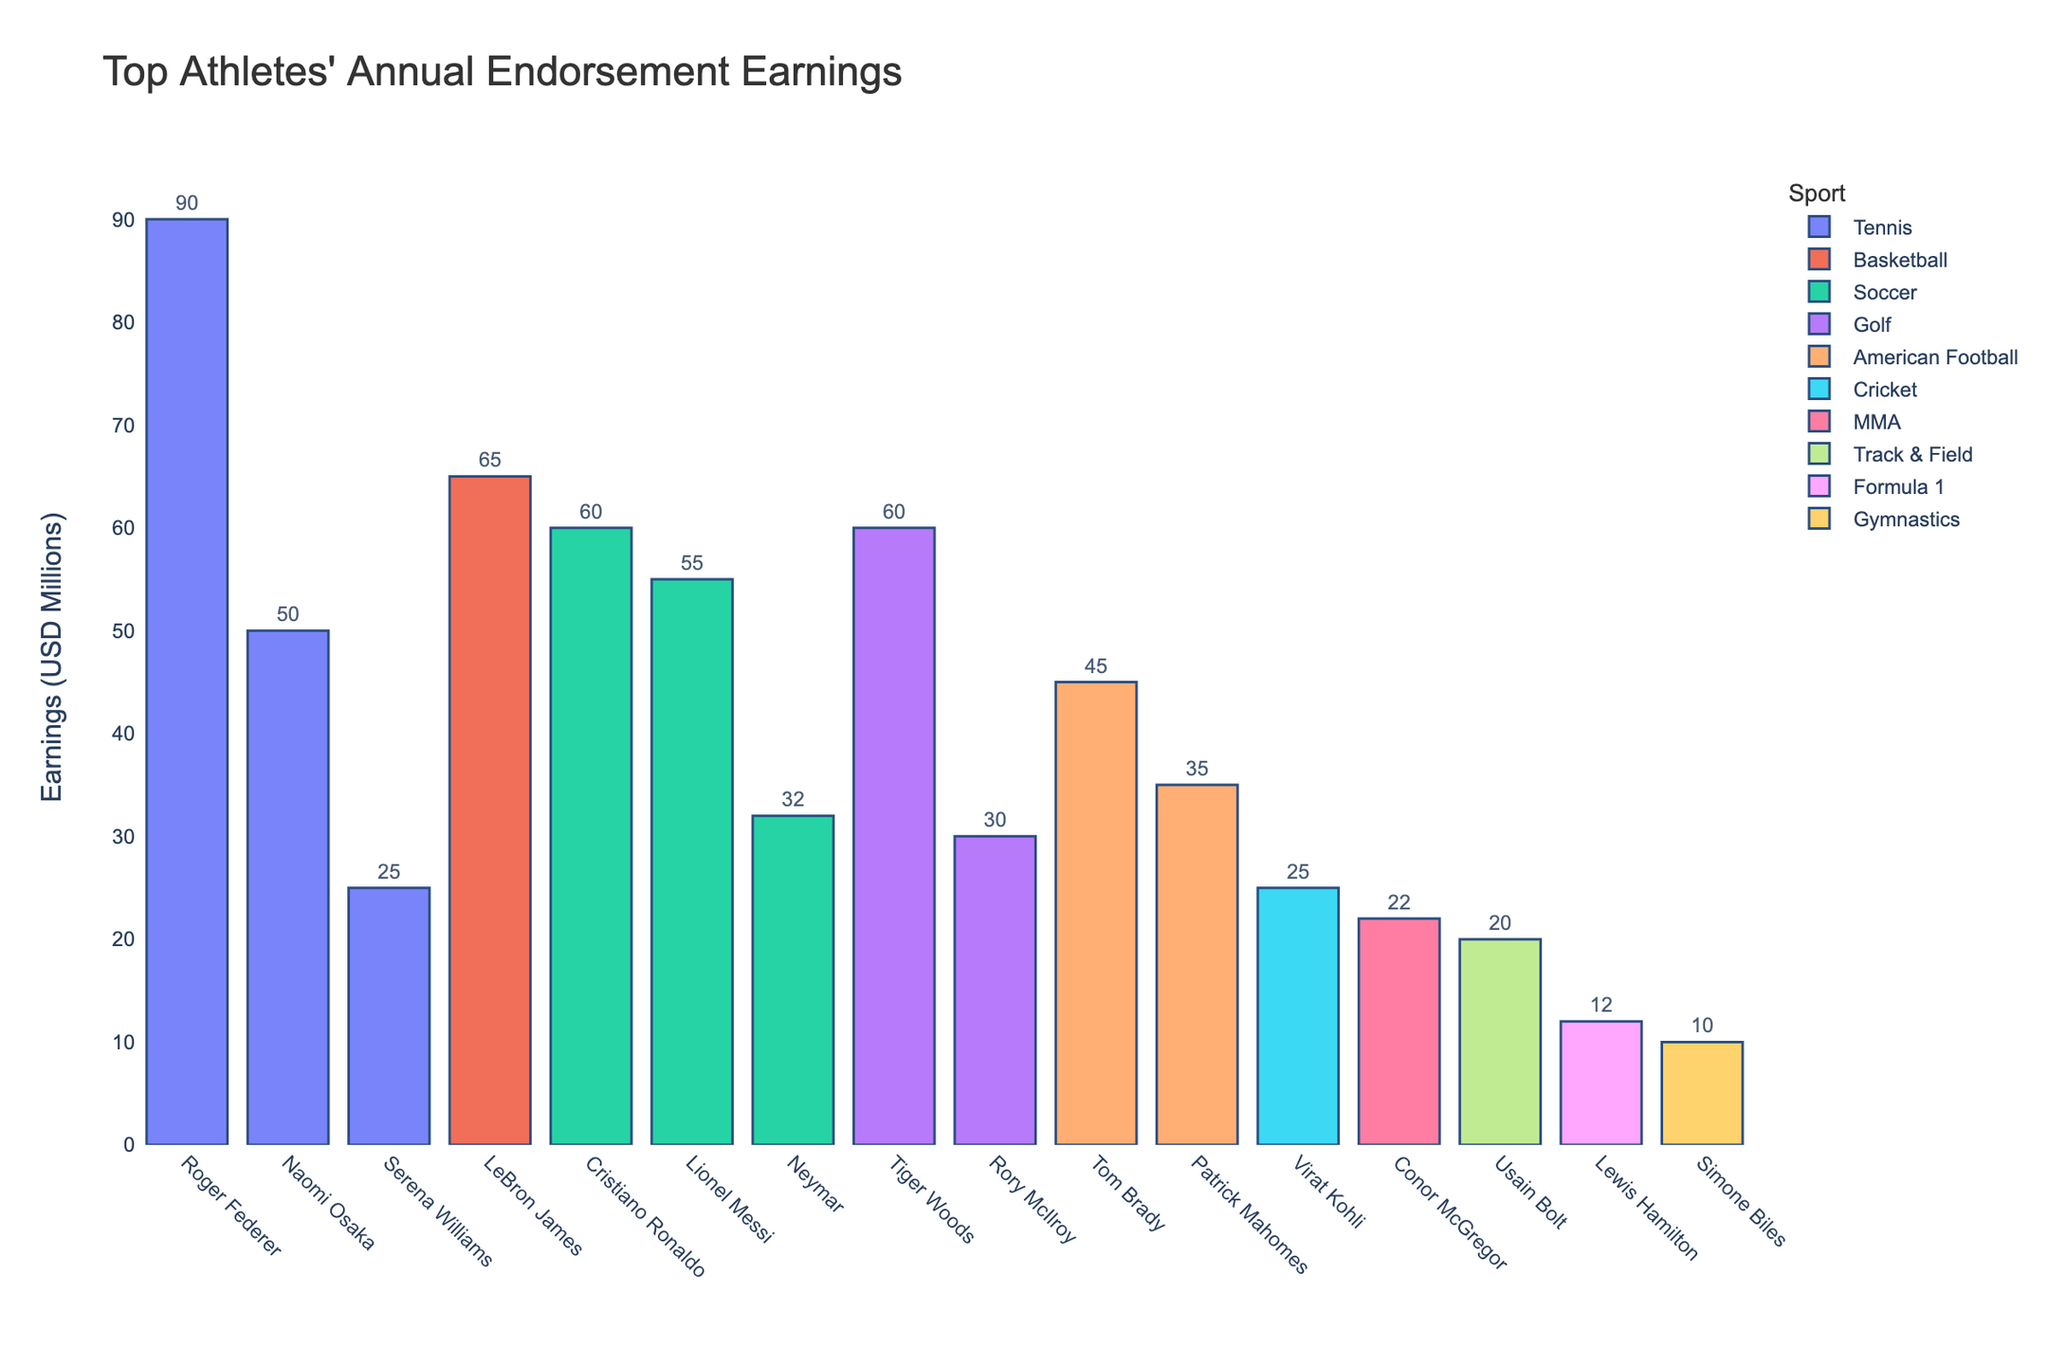Which athlete has the highest annual endorsement earnings? The chart shows different athletes and their earnings in a sorted order. The highest bar corresponds to Roger Federer, indicating the highest earnings.
Answer: Roger Federer Whose endorsement earnings are higher: LeBron James or Cristiano Ronaldo? The heights of the bars for LeBron James and Cristiano Ronaldo can be compared visually. LeBron James' bar is higher than Cristiano Ronaldo's.
Answer: LeBron James What is the difference in endorsement earnings between Serena Williams and Naomi Osaka? To find the difference, subtract Serena Williams' earnings (25 million) from Naomi Osaka's earnings (50 million). Hence, 50 - 25 = 25 million.
Answer: 25 million Which sport has the most athletes represented in the top endorsement earnings list? By counting the number of bars grouped by color (each color representing a sport), soccer has the most athletes (Cristiano Ronaldo, Lionel Messi, Neymar).
Answer: Soccer What is the combined annual endorsement earnings for the soccer players in the chart? Add the earnings of Cristiano Ronaldo (60 million), Lionel Messi (55 million), and Neymar (32 million). So, 60 + 55 + 32 = 147 million.
Answer: 147 million Among the tennis players, who has the lowest annual endorsement earnings? Compare the bars for the tennis players: Roger Federer, Serena Williams, and Naomi Osaka. Serena Williams' bar is the lowest.
Answer: Serena Williams How many athletes have annual endorsement earnings greater than 50 million? Identify and count the bars with heights surpassing the 50 million mark. Roger Federer, LeBron James, Cristiano Ronaldo, Lionel Messi, and Naomi Osaka all exceed 50 million, totaling 5 athletes.
Answer: 5 What is the difference in annual endorsement earnings between the highest and lowest earning athletes? The highest earnings are from Roger Federer (90 million), and the lowest are from Simone Biles (10 million). The difference is 90 - 10 = 80 million.
Answer: 80 million Which athlete in American Football has higher endorsement earnings, Tom Brady or Patrick Mahomes? Compare the bars for Tom Brady and Patrick Mahomes. Tom Brady's bar is taller than Patrick Mahomes'.
Answer: Tom Brady What is the average annual endorsement earnings of the athletes listed? Sum the earnings of all athletes and divide by the number of athletes. (90+65+60+55+32+25+50+60+30+20+10+45+35+25+12+22) / 16 = 636 / 16 = 39.75 million.
Answer: 39.75 million 